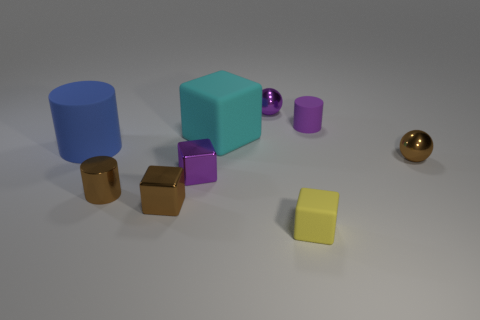Subtract all gray blocks. Subtract all yellow cylinders. How many blocks are left? 4 Add 1 small matte objects. How many objects exist? 10 Subtract all cubes. How many objects are left? 5 Subtract 0 gray blocks. How many objects are left? 9 Subtract all large green matte objects. Subtract all big cyan matte things. How many objects are left? 8 Add 6 large blue things. How many large blue things are left? 7 Add 6 big gray shiny objects. How many big gray shiny objects exist? 6 